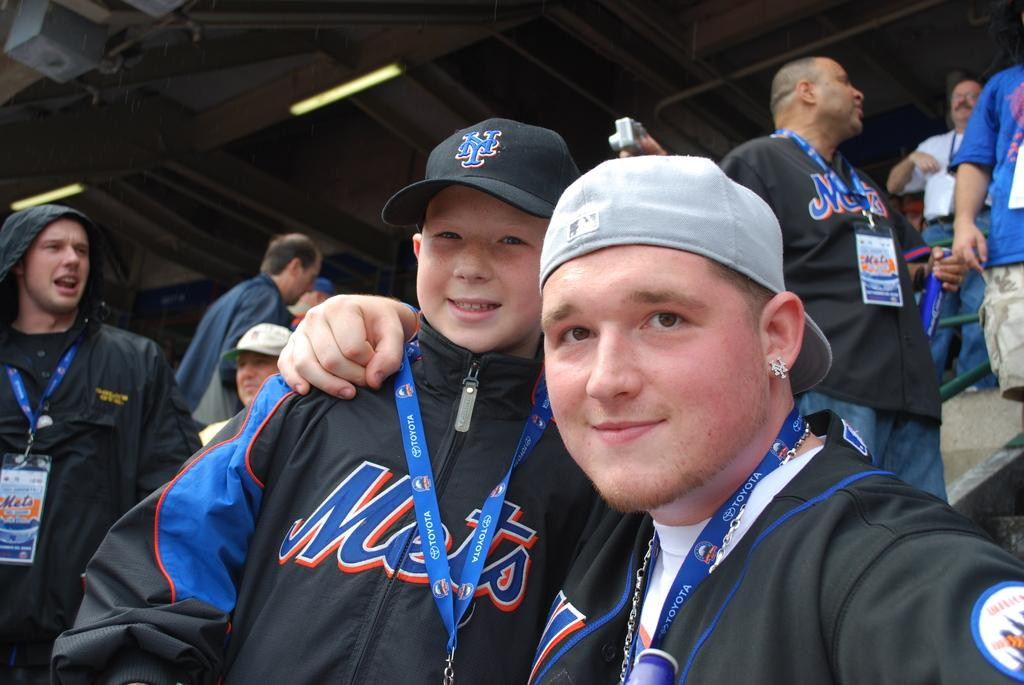<image>
Offer a succinct explanation of the picture presented. A child and a man are posing for a picture while wearing Mets team shirts. 